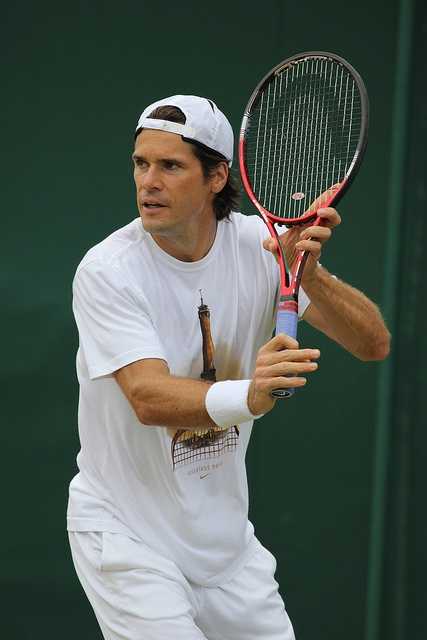Describe the objects in this image and their specific colors. I can see people in black, lightgray, and darkgray tones and tennis racket in black, gray, darkgray, and darkgreen tones in this image. 